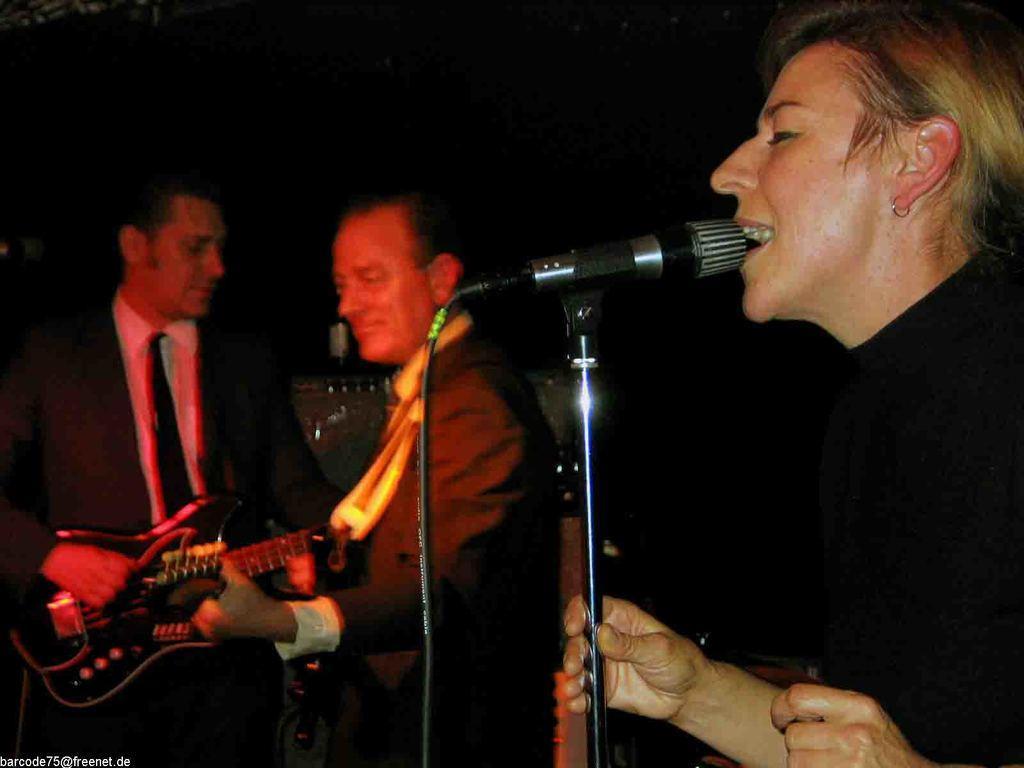Describe this image in one or two sentences. In this image i can see a person singing song in front of a micro phone at the back ground i can see two other persons playing guitar. 